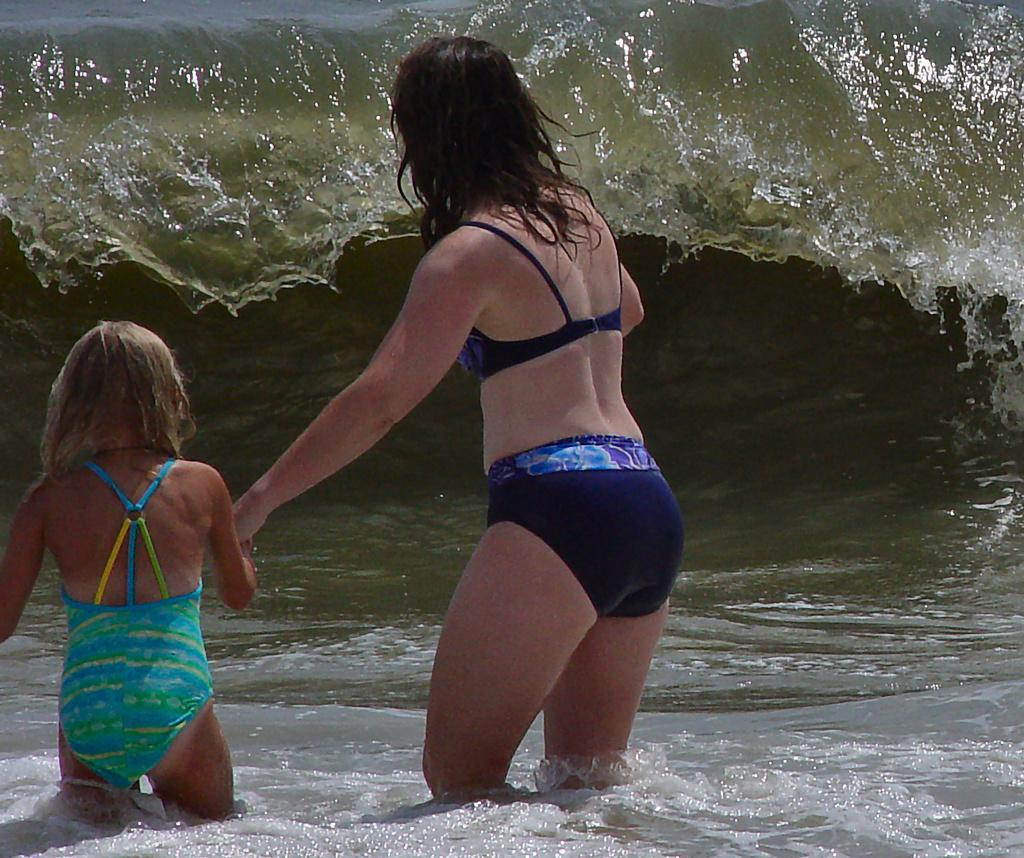Who is present in the image? There is a woman in the image. What is the woman doing in the image? The woman is holding a girl's hand. What activity are the woman and the girl engaged in? The woman and the girl are entering the sea. What type of power source is visible in the image? There is no power source visible in the image. Where is the stage located in the image? There is no stage present in the image. 